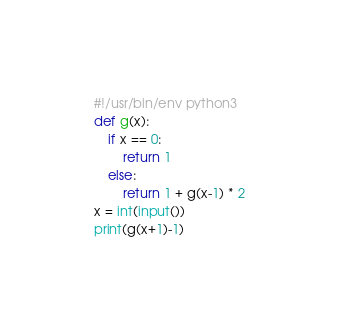Convert code to text. <code><loc_0><loc_0><loc_500><loc_500><_Python_>#!/usr/bin/env python3
def g(x):
    if x == 0:
        return 1
    else:
        return 1 + g(x-1) * 2
x = int(input())
print(g(x+1)-1)
</code> 